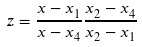Convert formula to latex. <formula><loc_0><loc_0><loc_500><loc_500>z = \frac { x - x _ { 1 } } { x - x _ { 4 } } \frac { x _ { 2 } - x _ { 4 } } { x _ { 2 } - x _ { 1 } }</formula> 